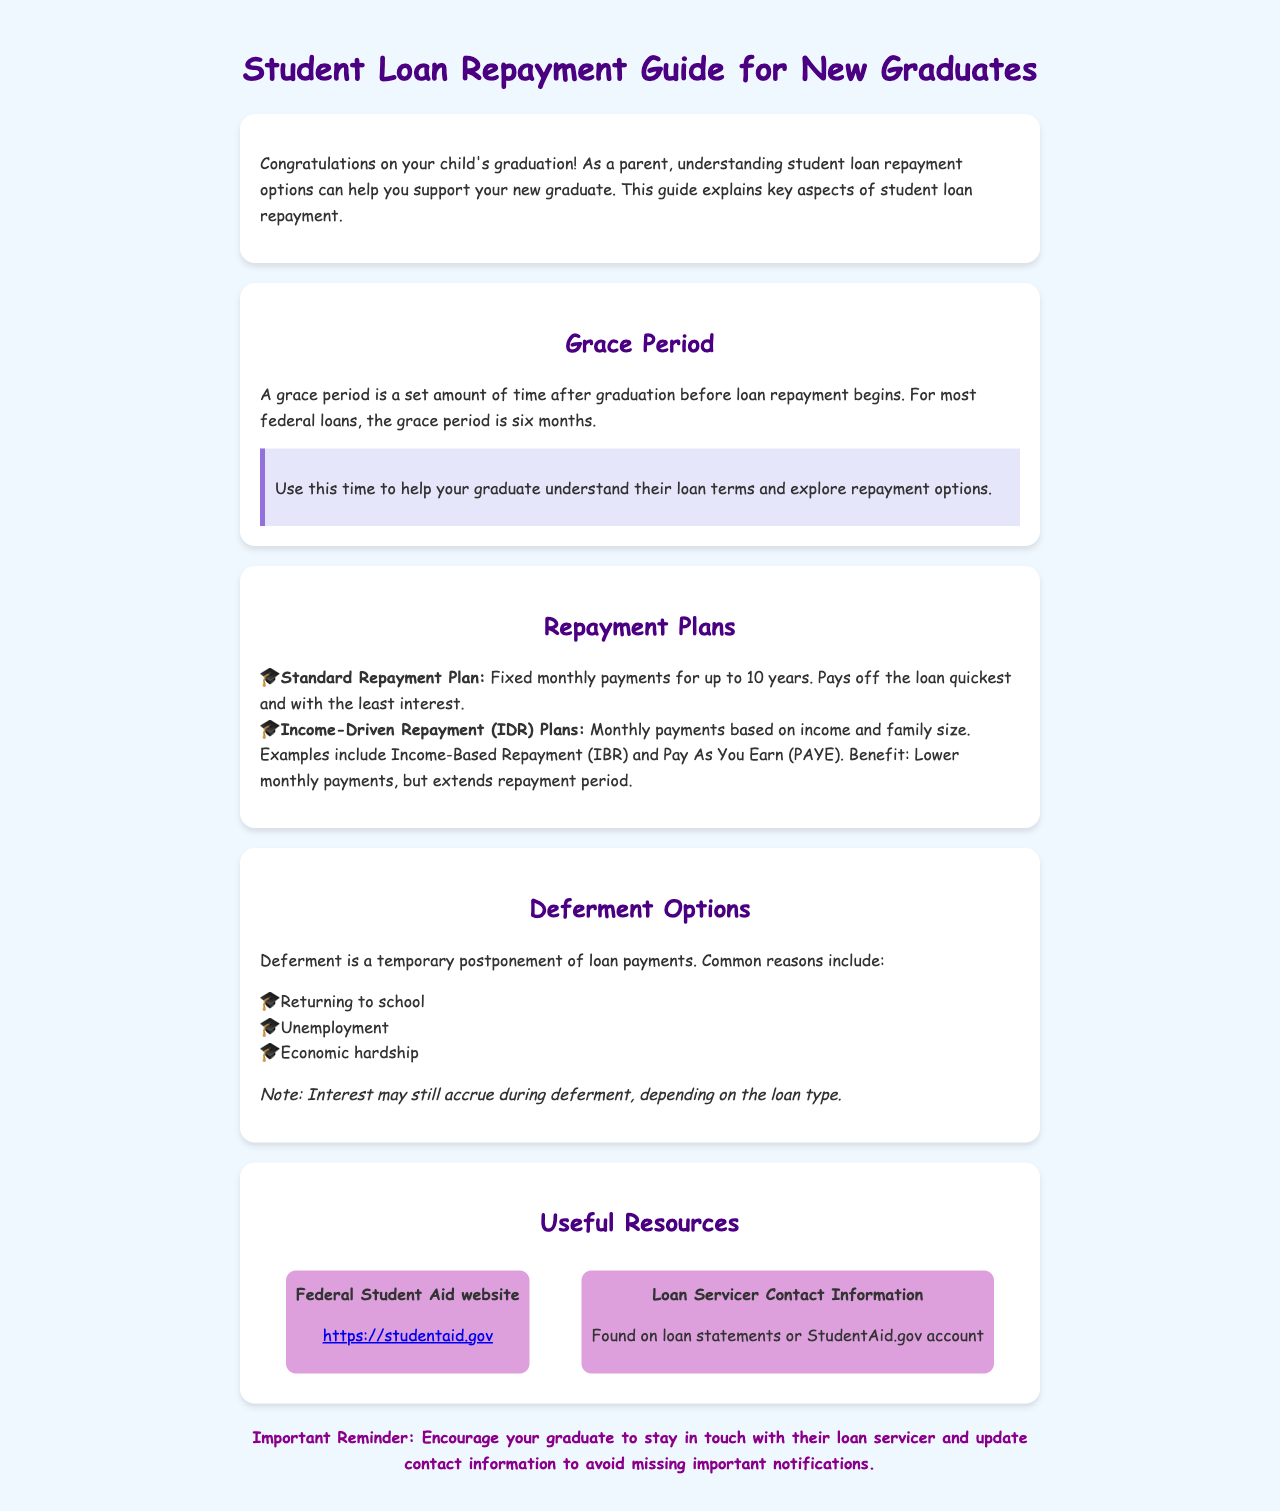What is the grace period length for most federal loans? The grace period is a set time after graduation, commonly six months before loan repayment begins.
Answer: six months What repayment plan pays off the loan quickest? The Standard Repayment Plan has fixed monthly payments for up to 10 years, thus paying off the loan the quickest.
Answer: Standard Repayment Plan What are two common reasons for deferment? Deferment can occur for various reasons, including returning to school and unemployment.
Answer: returning to school, unemployment What is a benefit of Income-Driven Repayment Plans? Income-Driven Repayment Plans allow lower monthly payments based on income and family size.
Answer: Lower monthly payments Where can you find loan servicer contact information? Loan servicer contact information can be found on loan statements or StudentAid.gov account.
Answer: loan statements or StudentAid.gov account What should graduates do to avoid missing important notifications? Graduates should stay in touch with their loan servicer and update their contact information.
Answer: Update contact information 